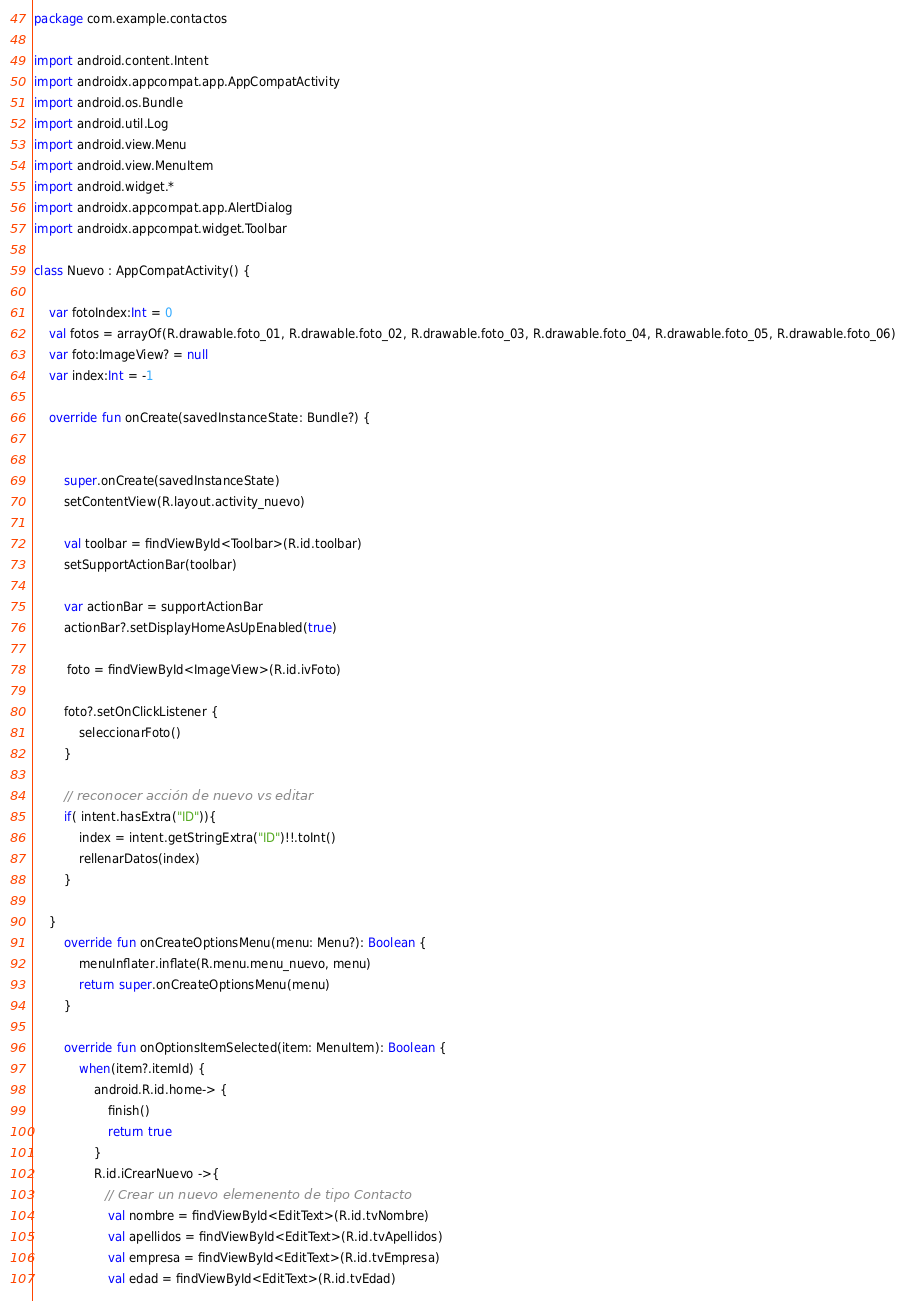Convert code to text. <code><loc_0><loc_0><loc_500><loc_500><_Kotlin_>package com.example.contactos

import android.content.Intent
import androidx.appcompat.app.AppCompatActivity
import android.os.Bundle
import android.util.Log
import android.view.Menu
import android.view.MenuItem
import android.widget.*
import androidx.appcompat.app.AlertDialog
import androidx.appcompat.widget.Toolbar

class Nuevo : AppCompatActivity() {

    var fotoIndex:Int = 0
    val fotos = arrayOf(R.drawable.foto_01, R.drawable.foto_02, R.drawable.foto_03, R.drawable.foto_04, R.drawable.foto_05, R.drawable.foto_06)
    var foto:ImageView? = null
    var index:Int = -1

    override fun onCreate(savedInstanceState: Bundle?) {


        super.onCreate(savedInstanceState)
        setContentView(R.layout.activity_nuevo)

        val toolbar = findViewById<Toolbar>(R.id.toolbar)
        setSupportActionBar(toolbar)

        var actionBar = supportActionBar
        actionBar?.setDisplayHomeAsUpEnabled(true)

         foto = findViewById<ImageView>(R.id.ivFoto)

        foto?.setOnClickListener {
            seleccionarFoto()
        }

        // reconocer acción de nuevo vs editar
        if( intent.hasExtra("ID")){
            index = intent.getStringExtra("ID")!!.toInt()
            rellenarDatos(index)
        }

    }
        override fun onCreateOptionsMenu(menu: Menu?): Boolean {
            menuInflater.inflate(R.menu.menu_nuevo, menu)
            return super.onCreateOptionsMenu(menu)
        }

        override fun onOptionsItemSelected(item: MenuItem): Boolean {
            when(item?.itemId) {
                android.R.id.home-> {
                    finish()
                    return true
                }
                R.id.iCrearNuevo ->{
                   // Crear un nuevo elemenento de tipo Contacto
                    val nombre = findViewById<EditText>(R.id.tvNombre)
                    val apellidos = findViewById<EditText>(R.id.tvApellidos)
                    val empresa = findViewById<EditText>(R.id.tvEmpresa)
                    val edad = findViewById<EditText>(R.id.tvEdad)</code> 